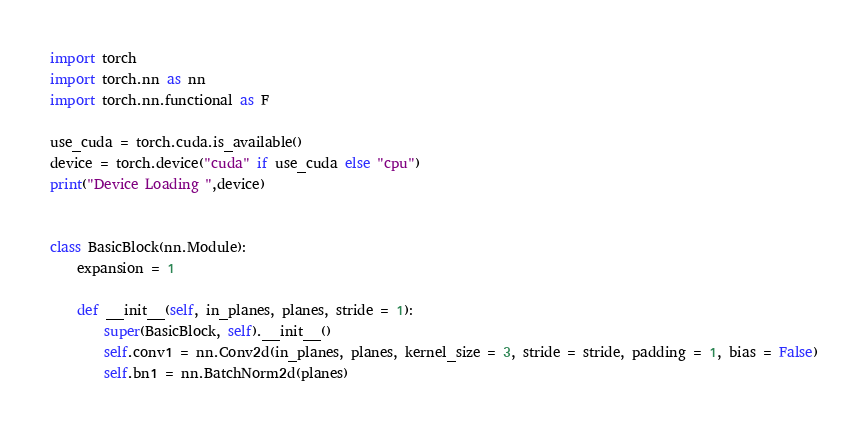Convert code to text. <code><loc_0><loc_0><loc_500><loc_500><_Python_>import torch
import torch.nn as nn
import torch.nn.functional as F

use_cuda = torch.cuda.is_available()
device = torch.device("cuda" if use_cuda else "cpu")
print("Device Loading ",device)


class BasicBlock(nn.Module):
    expansion = 1

    def __init__(self, in_planes, planes, stride = 1):
        super(BasicBlock, self).__init__()
        self.conv1 = nn.Conv2d(in_planes, planes, kernel_size = 3, stride = stride, padding = 1, bias = False)
        self.bn1 = nn.BatchNorm2d(planes)</code> 